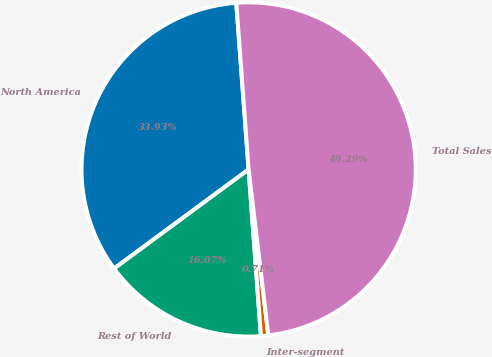<chart> <loc_0><loc_0><loc_500><loc_500><pie_chart><fcel>North America<fcel>Rest of World<fcel>Inter-segment<fcel>Total Sales<nl><fcel>33.93%<fcel>16.07%<fcel>0.71%<fcel>49.29%<nl></chart> 